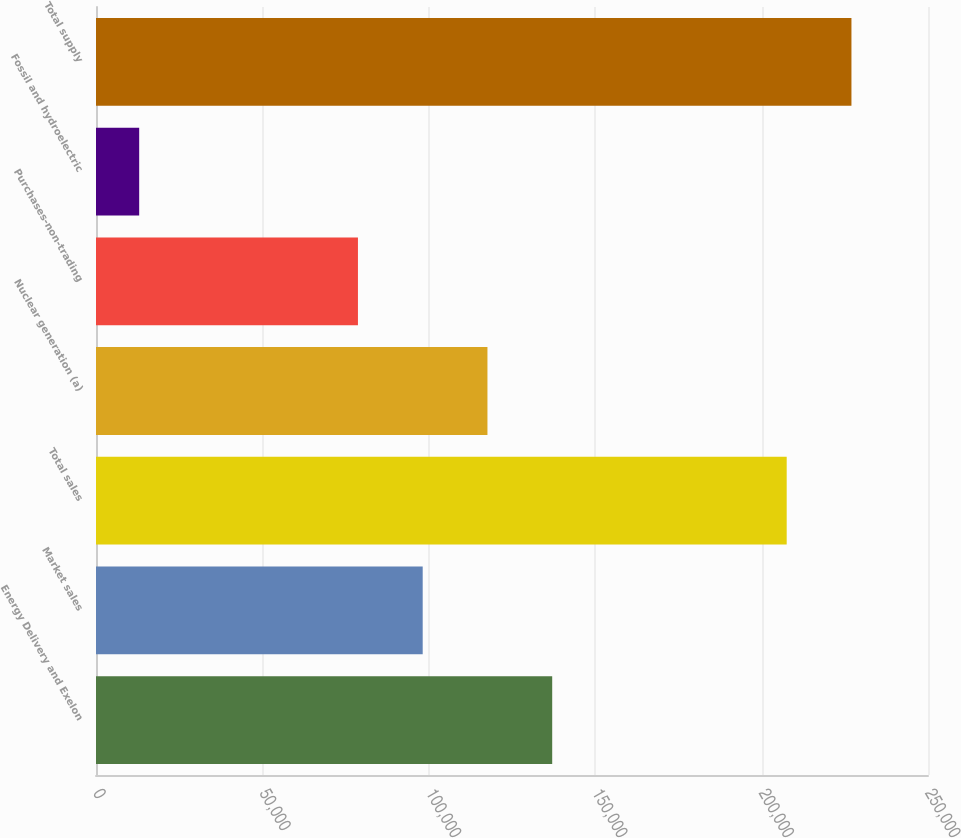Convert chart to OTSL. <chart><loc_0><loc_0><loc_500><loc_500><bar_chart><fcel>Energy Delivery and Exelon<fcel>Market sales<fcel>Total sales<fcel>Nuclear generation (a)<fcel>Purchases-non-trading<fcel>Fossil and hydroelectric<fcel>Total supply<nl><fcel>137079<fcel>98166.4<fcel>207540<fcel>117623<fcel>78710<fcel>12976<fcel>226996<nl></chart> 